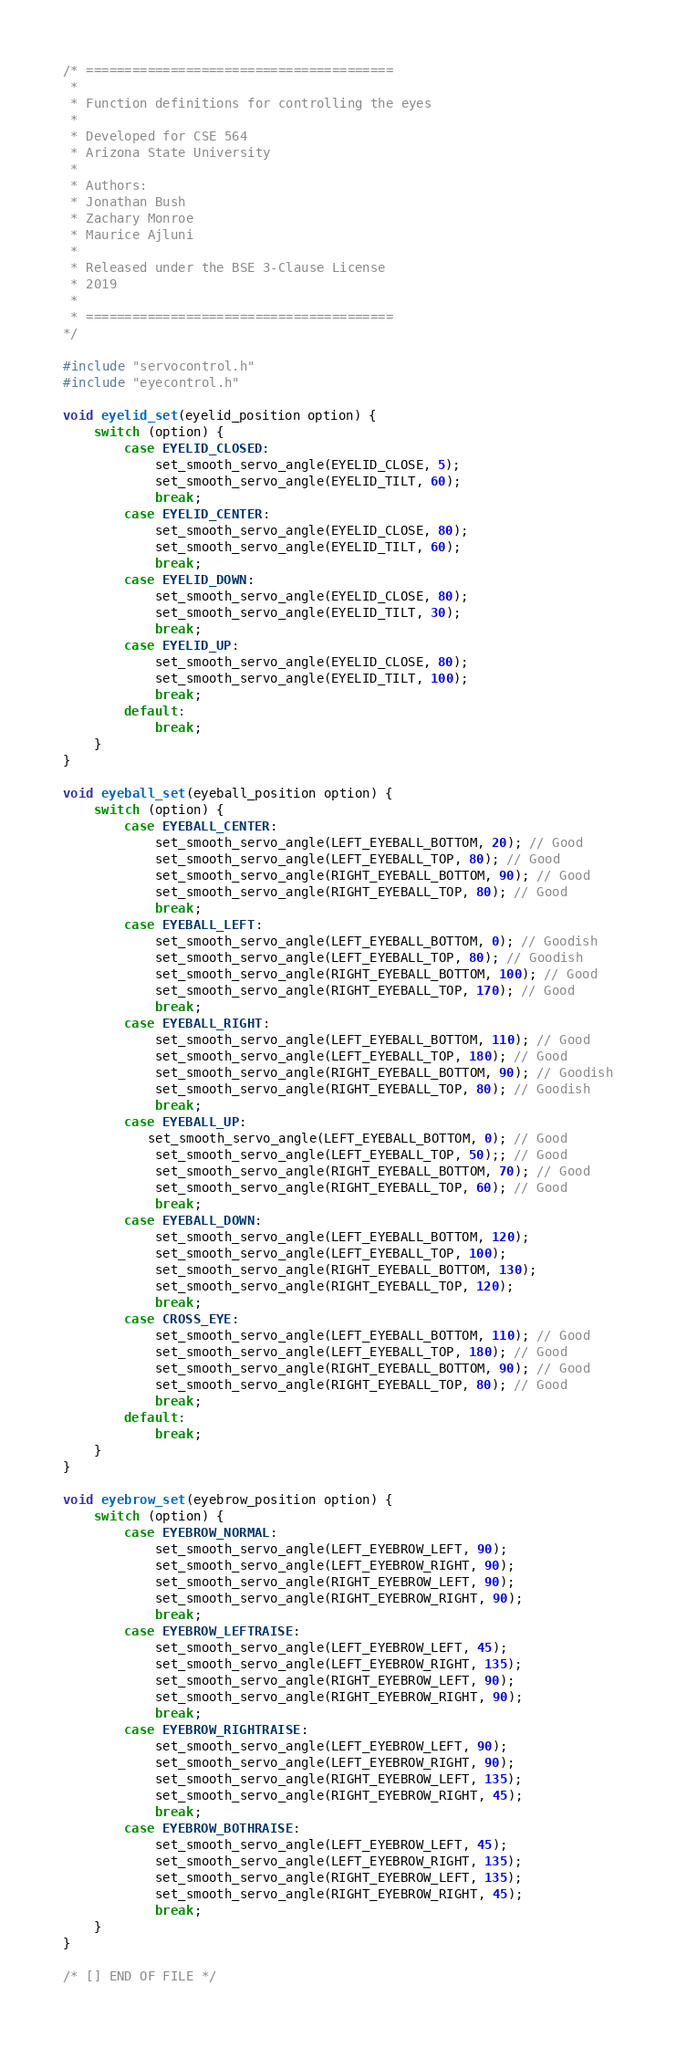<code> <loc_0><loc_0><loc_500><loc_500><_C_>/* ========================================
 *
 * Function definitions for controlling the eyes
 * 
 * Developed for CSE 564
 * Arizona State University
 * 
 * Authors:
 * Jonathan Bush
 * Zachary Monroe
 * Maurice Ajluni
 *
 * Released under the BSE 3-Clause License
 * 2019
 *
 * ========================================
*/

#include "servocontrol.h"
#include "eyecontrol.h"

void eyelid_set(eyelid_position option) {
    switch (option) {
        case EYELID_CLOSED:
            set_smooth_servo_angle(EYELID_CLOSE, 5);
            set_smooth_servo_angle(EYELID_TILT, 60);
            break;
        case EYELID_CENTER:
            set_smooth_servo_angle(EYELID_CLOSE, 80);
            set_smooth_servo_angle(EYELID_TILT, 60);
            break;
        case EYELID_DOWN:
            set_smooth_servo_angle(EYELID_CLOSE, 80);
            set_smooth_servo_angle(EYELID_TILT, 30);
            break;
        case EYELID_UP:
            set_smooth_servo_angle(EYELID_CLOSE, 80);
            set_smooth_servo_angle(EYELID_TILT, 100);
            break;
        default:
            break;
    }
}

void eyeball_set(eyeball_position option) {
    switch (option) {
        case EYEBALL_CENTER:
            set_smooth_servo_angle(LEFT_EYEBALL_BOTTOM, 20); // Good
            set_smooth_servo_angle(LEFT_EYEBALL_TOP, 80); // Good
            set_smooth_servo_angle(RIGHT_EYEBALL_BOTTOM, 90); // Good
            set_smooth_servo_angle(RIGHT_EYEBALL_TOP, 80); // Good
            break;
        case EYEBALL_LEFT:
            set_smooth_servo_angle(LEFT_EYEBALL_BOTTOM, 0); // Goodish
            set_smooth_servo_angle(LEFT_EYEBALL_TOP, 80); // Goodish
            set_smooth_servo_angle(RIGHT_EYEBALL_BOTTOM, 100); // Good
            set_smooth_servo_angle(RIGHT_EYEBALL_TOP, 170); // Good
            break;
        case EYEBALL_RIGHT:
            set_smooth_servo_angle(LEFT_EYEBALL_BOTTOM, 110); // Good
            set_smooth_servo_angle(LEFT_EYEBALL_TOP, 180); // Good
            set_smooth_servo_angle(RIGHT_EYEBALL_BOTTOM, 90); // Goodish
            set_smooth_servo_angle(RIGHT_EYEBALL_TOP, 80); // Goodish
            break;
        case EYEBALL_UP:
           set_smooth_servo_angle(LEFT_EYEBALL_BOTTOM, 0); // Good
            set_smooth_servo_angle(LEFT_EYEBALL_TOP, 50);; // Good
            set_smooth_servo_angle(RIGHT_EYEBALL_BOTTOM, 70); // Good
            set_smooth_servo_angle(RIGHT_EYEBALL_TOP, 60); // Good
            break;
        case EYEBALL_DOWN:
            set_smooth_servo_angle(LEFT_EYEBALL_BOTTOM, 120);
            set_smooth_servo_angle(LEFT_EYEBALL_TOP, 100);
            set_smooth_servo_angle(RIGHT_EYEBALL_BOTTOM, 130);
            set_smooth_servo_angle(RIGHT_EYEBALL_TOP, 120);
            break;
        case CROSS_EYE:
            set_smooth_servo_angle(LEFT_EYEBALL_BOTTOM, 110); // Good
            set_smooth_servo_angle(LEFT_EYEBALL_TOP, 180); // Good
            set_smooth_servo_angle(RIGHT_EYEBALL_BOTTOM, 90); // Good
            set_smooth_servo_angle(RIGHT_EYEBALL_TOP, 80); // Good
            break;
        default:
            break;
    }
}

void eyebrow_set(eyebrow_position option) {
    switch (option) {
        case EYEBROW_NORMAL:
            set_smooth_servo_angle(LEFT_EYEBROW_LEFT, 90);
            set_smooth_servo_angle(LEFT_EYEBROW_RIGHT, 90);
            set_smooth_servo_angle(RIGHT_EYEBROW_LEFT, 90);
            set_smooth_servo_angle(RIGHT_EYEBROW_RIGHT, 90);
            break;
        case EYEBROW_LEFTRAISE:
            set_smooth_servo_angle(LEFT_EYEBROW_LEFT, 45);
            set_smooth_servo_angle(LEFT_EYEBROW_RIGHT, 135);
            set_smooth_servo_angle(RIGHT_EYEBROW_LEFT, 90);
            set_smooth_servo_angle(RIGHT_EYEBROW_RIGHT, 90);
            break;
        case EYEBROW_RIGHTRAISE:
            set_smooth_servo_angle(LEFT_EYEBROW_LEFT, 90);
            set_smooth_servo_angle(LEFT_EYEBROW_RIGHT, 90);
            set_smooth_servo_angle(RIGHT_EYEBROW_LEFT, 135);
            set_smooth_servo_angle(RIGHT_EYEBROW_RIGHT, 45);
            break;
        case EYEBROW_BOTHRAISE:
            set_smooth_servo_angle(LEFT_EYEBROW_LEFT, 45);
            set_smooth_servo_angle(LEFT_EYEBROW_RIGHT, 135);
            set_smooth_servo_angle(RIGHT_EYEBROW_LEFT, 135);
            set_smooth_servo_angle(RIGHT_EYEBROW_RIGHT, 45);
            break;
    }
}

/* [] END OF FILE */
</code> 